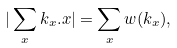Convert formula to latex. <formula><loc_0><loc_0><loc_500><loc_500>| \sum _ { x } k _ { x } . x | = \sum _ { x } w ( k _ { x } ) ,</formula> 